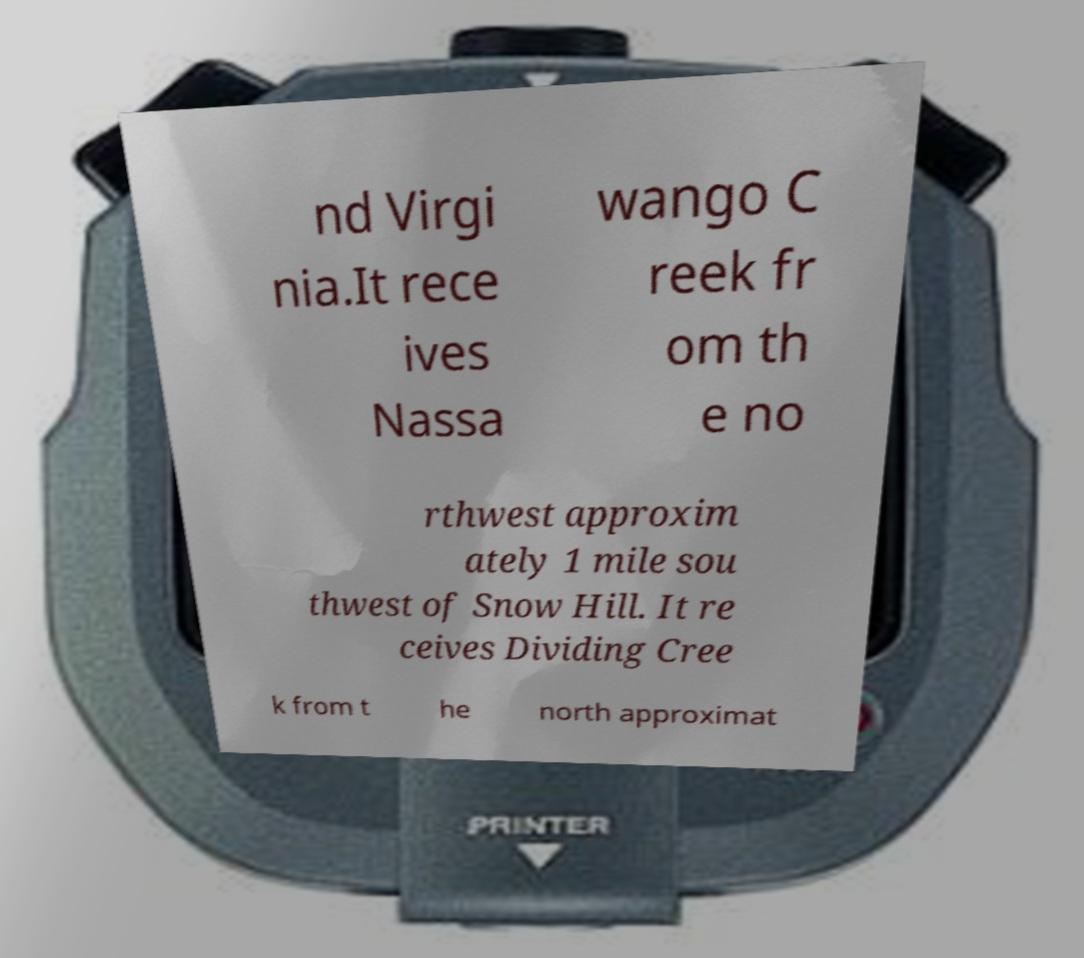What messages or text are displayed in this image? I need them in a readable, typed format. nd Virgi nia.It rece ives Nassa wango C reek fr om th e no rthwest approxim ately 1 mile sou thwest of Snow Hill. It re ceives Dividing Cree k from t he north approximat 